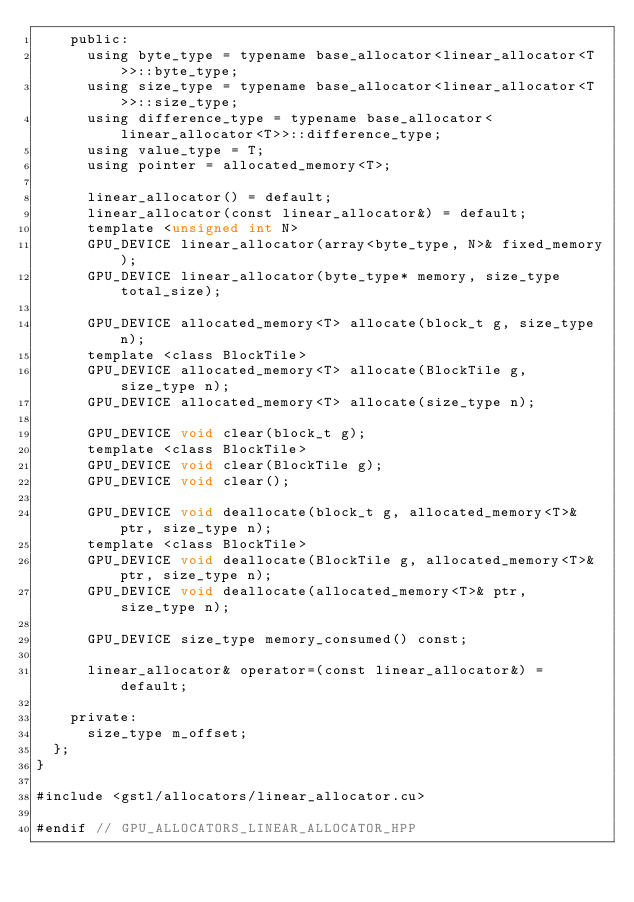<code> <loc_0><loc_0><loc_500><loc_500><_Cuda_>		public:
			using byte_type = typename base_allocator<linear_allocator<T>>::byte_type;
			using size_type = typename base_allocator<linear_allocator<T>>::size_type;
			using difference_type = typename base_allocator<linear_allocator<T>>::difference_type;
			using value_type = T;
			using pointer = allocated_memory<T>;

			linear_allocator() = default;
			linear_allocator(const linear_allocator&) = default;
			template <unsigned int N>
			GPU_DEVICE linear_allocator(array<byte_type, N>& fixed_memory);
			GPU_DEVICE linear_allocator(byte_type* memory, size_type total_size);

			GPU_DEVICE allocated_memory<T> allocate(block_t g, size_type n);
			template <class BlockTile>
			GPU_DEVICE allocated_memory<T> allocate(BlockTile g, size_type n);
			GPU_DEVICE allocated_memory<T> allocate(size_type n);

			GPU_DEVICE void clear(block_t g);
			template <class BlockTile>
			GPU_DEVICE void clear(BlockTile g);
			GPU_DEVICE void clear();

			GPU_DEVICE void deallocate(block_t g, allocated_memory<T>& ptr, size_type n);
			template <class BlockTile>
			GPU_DEVICE void deallocate(BlockTile g, allocated_memory<T>& ptr, size_type n);
			GPU_DEVICE void deallocate(allocated_memory<T>& ptr, size_type n);

			GPU_DEVICE size_type memory_consumed() const;

			linear_allocator& operator=(const linear_allocator&) = default;

		private:
			size_type m_offset;
	};
}

#include <gstl/allocators/linear_allocator.cu>

#endif // GPU_ALLOCATORS_LINEAR_ALLOCATOR_HPP
</code> 